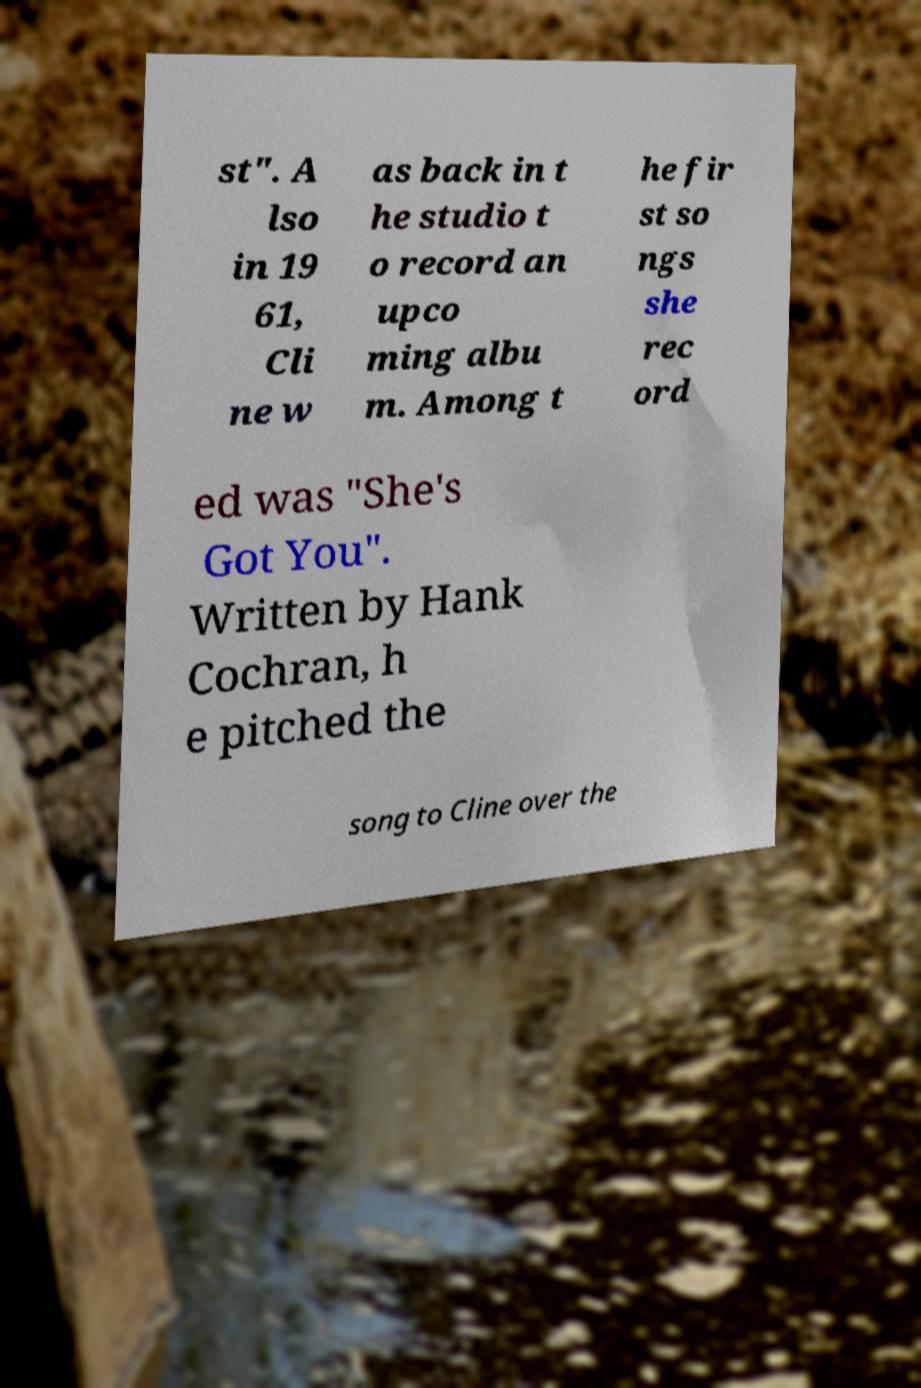Please identify and transcribe the text found in this image. st". A lso in 19 61, Cli ne w as back in t he studio t o record an upco ming albu m. Among t he fir st so ngs she rec ord ed was "She's Got You". Written by Hank Cochran, h e pitched the song to Cline over the 